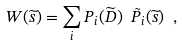<formula> <loc_0><loc_0><loc_500><loc_500>W ( \widetilde { s } ) = \sum _ { i } P _ { i } ( \widetilde { D } ) \ \tilde { P } _ { i } ( \widetilde { s } ) \ ,</formula> 